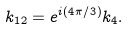Convert formula to latex. <formula><loc_0><loc_0><loc_500><loc_500>k _ { 1 2 } = e ^ { i ( 4 \pi / 3 ) } k _ { 4 } .</formula> 